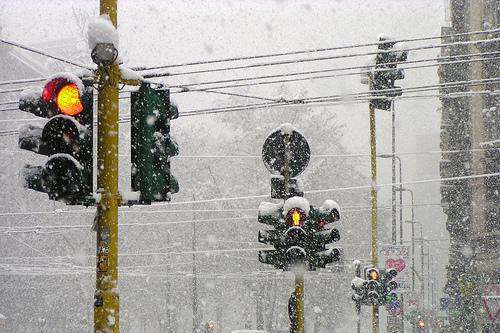Question: why is there snow?
Choices:
A. Because it is sunny.
B. Because it is raining.
C. It is spring.
D. Blizzard.
Answer with the letter. Answer: D Question: what is the condition?
Choices:
A. Blizzard.
B. Sunny.
C. Cloudy.
D. Clear.
Answer with the letter. Answer: A Question: what color is the snow?
Choices:
A. White.
B. Yellow.
C. Grey.
D. Black.
Answer with the letter. Answer: A 